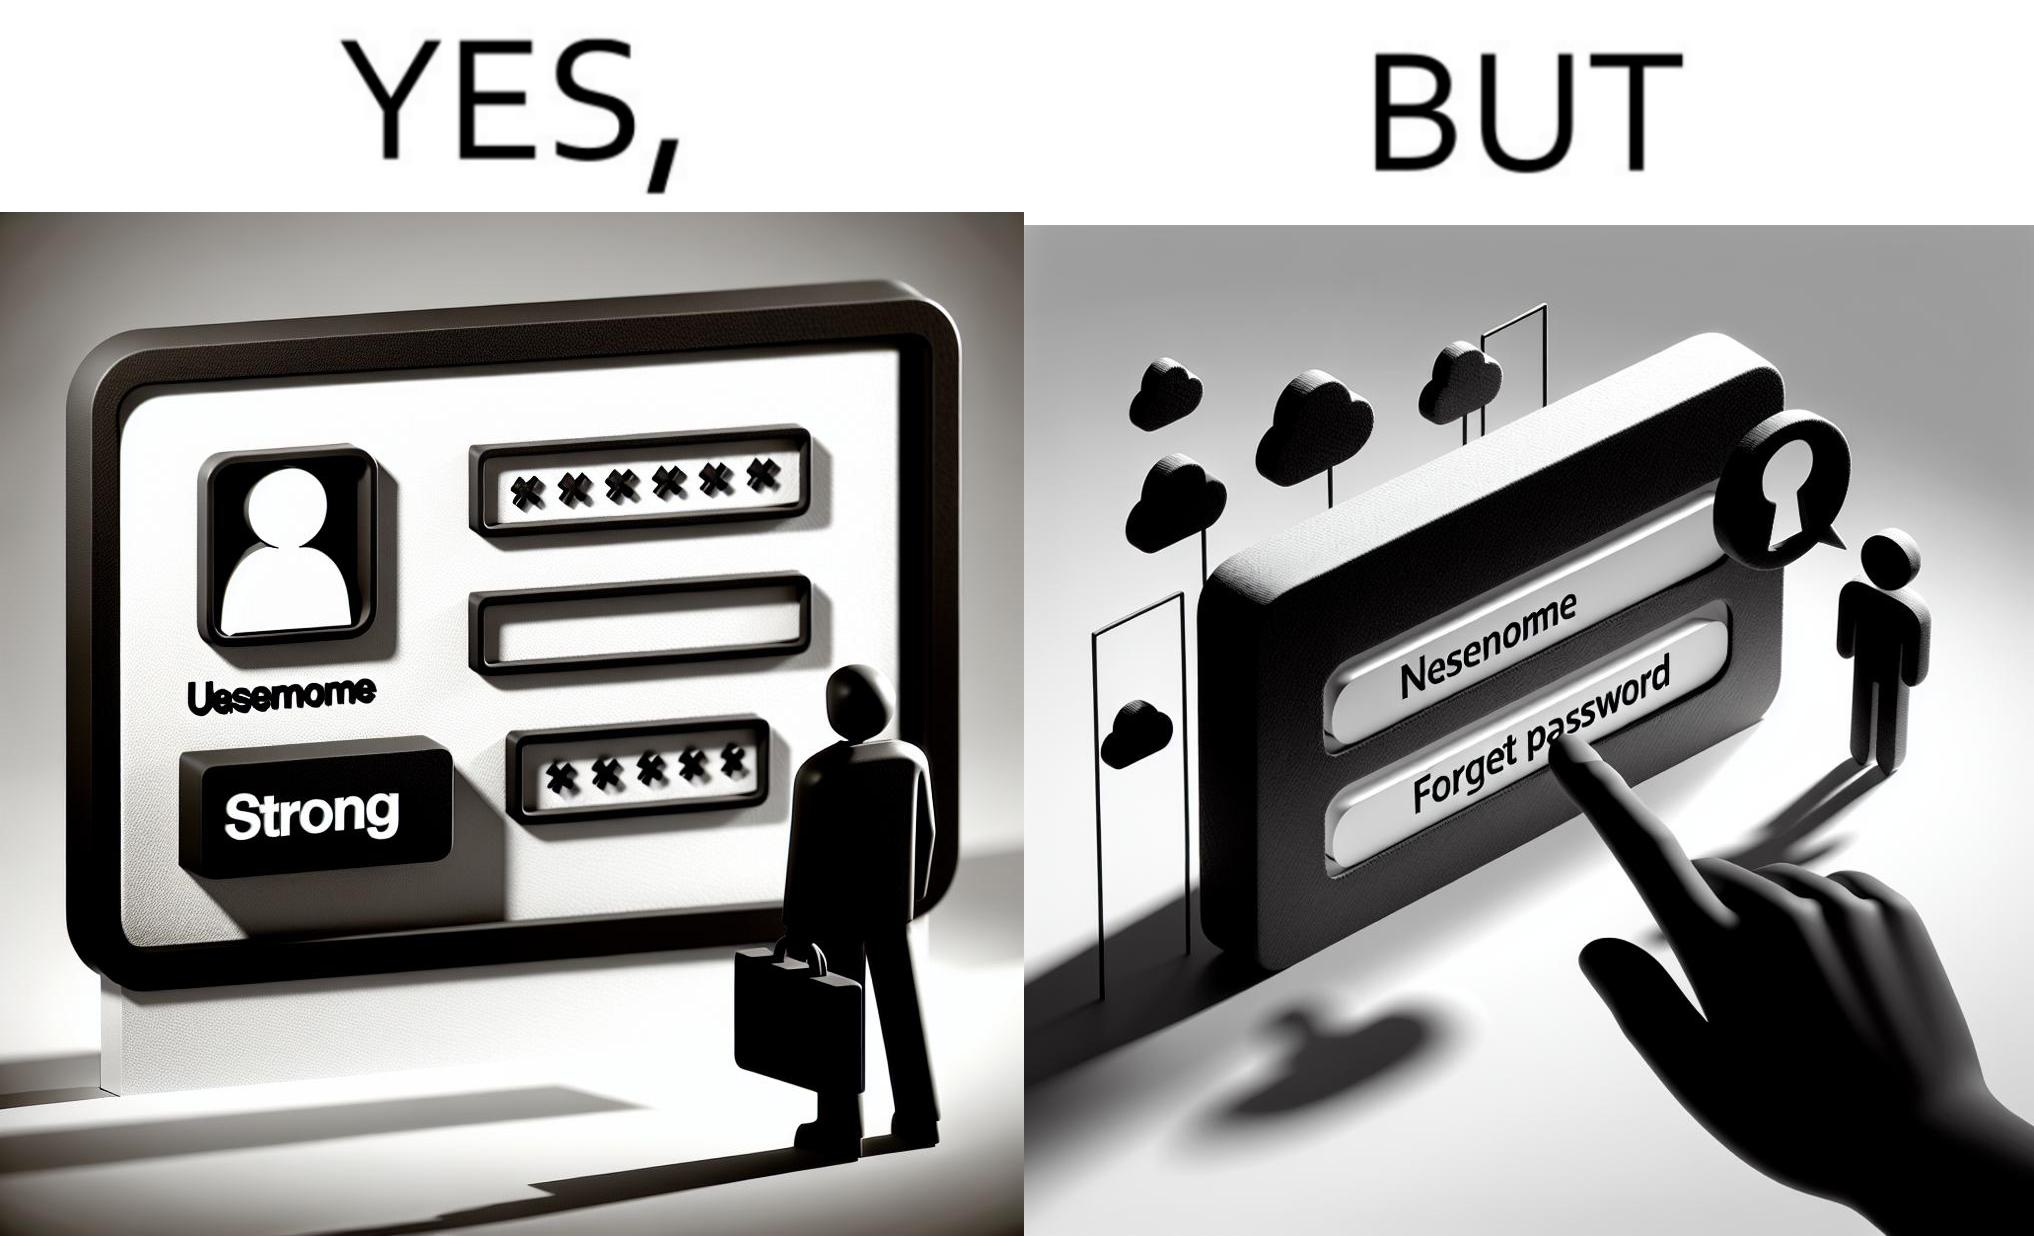Would you classify this image as satirical? Yes, this image is satirical. 